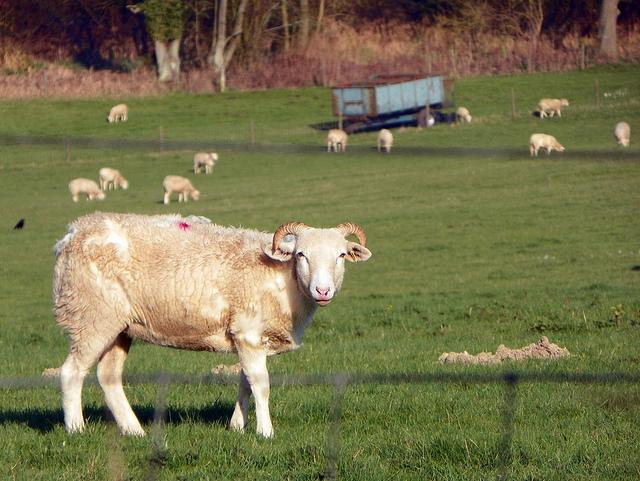Why do sheep have horns? Please explain your reasoning. shock-absorbers. They protect the sheep from the their head butting means of interacting with each other. 